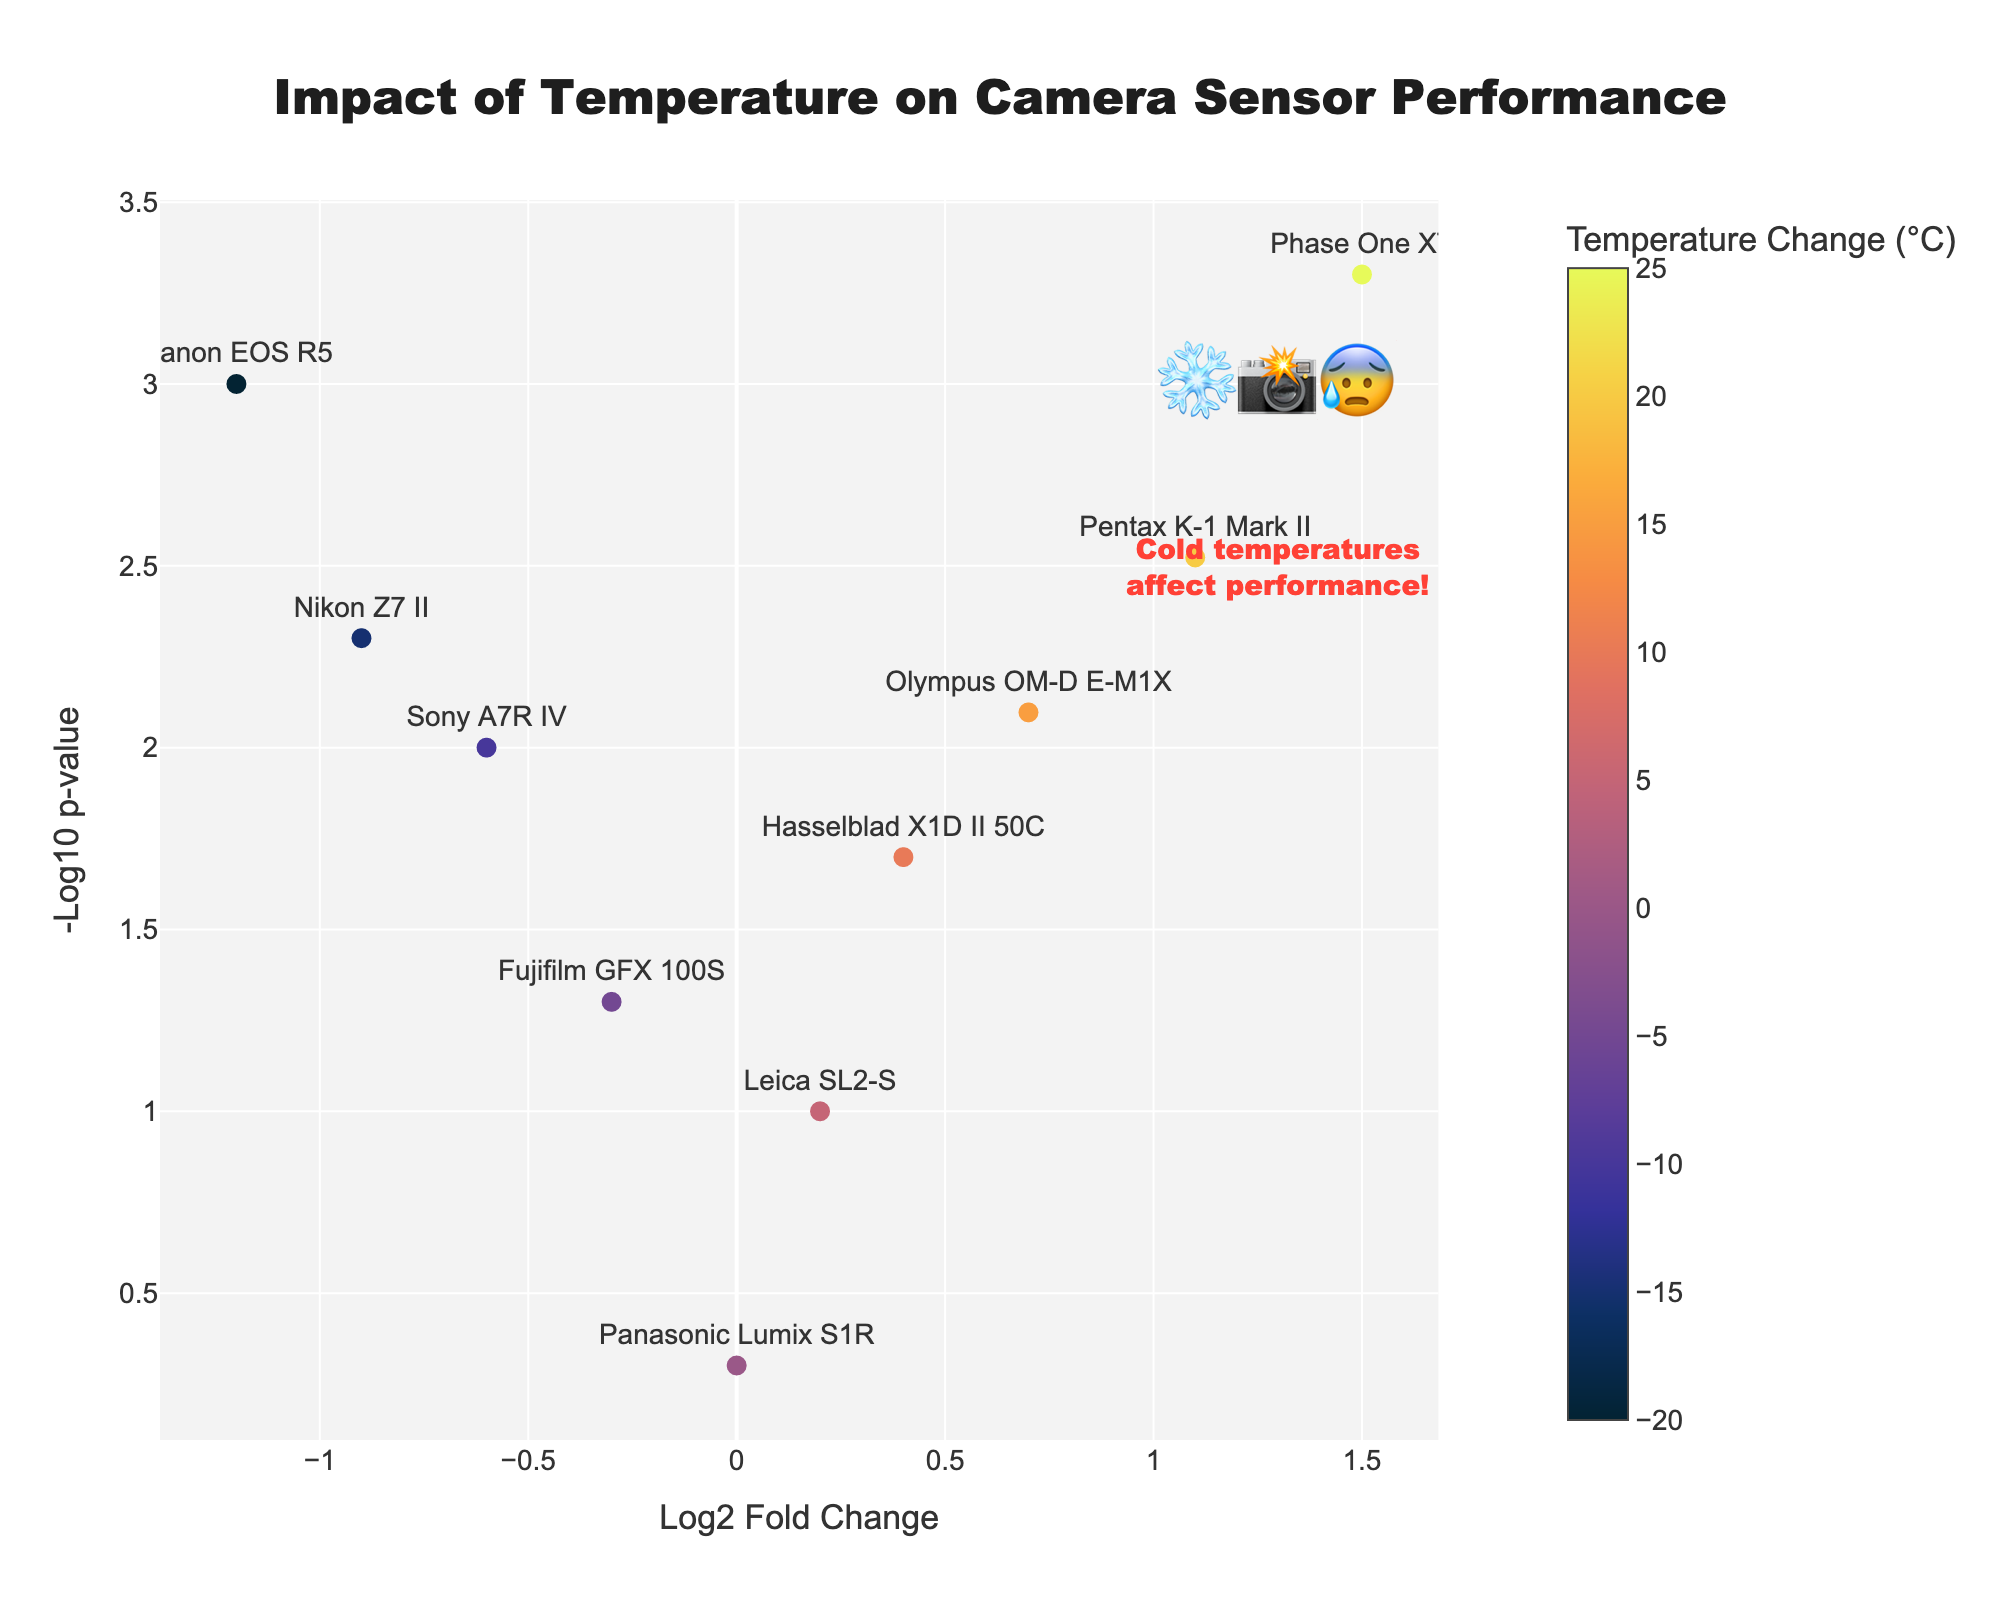what is the title of the figure? The title is typically displayed at the top of the figure. In this plot, it's centered at the top and prominently sized. It reads, "Impact of Temperature on Camera Sensor Performance".
Answer: Impact of Temperature on Camera Sensor Performance How many camera models are included in the figure? Count the number of different text labels representing camera models in the scatter plot. There are 10 different camera models.
Answer: 10 Which camera shows the largest impact due to cold temperatures? Look for the most negative log2 fold change value and identify the corresponding camera model. Canon EOS R5 shows the largest negative impact with a log2 fold change of -1.2.
Answer: Canon EOS R5 Which camera shows the least impact (close to no change) due to temperature? Look for the log2 fold change value closest to 0. Panasonic Lumix S1R has a log2 fold change of 0, indicating the least impact.
Answer: Panasonic Lumix S1R Are there more cameras positively or negatively affected by temperature changes? Compare the number of data points on the right side (positive log2 fold change) to those on the left side (negative log2 fold change). There are 6 cameras positively affected and 4 cameras negatively affected.
Answer: More positively affected What is the camera with the highest positive log2 fold change value? Identify the camera model with the highest log2 fold change value. The Phase One XT has the highest positive log2 fold change at 1.5.
Answer: Phase One XT Which camera model has the most statistically significant impact according to the p-values? Check for the camera model with the highest value on the y-axis (-log10(p-value)). Phase One XT has the highest -log10(p-value) of 3.3, indicating the most statistically significant impact.
Answer: Phase One XT What is the temperature change difference between the cameras with the highest and lowest log2 fold changes? Find the difference in temperature change values between Phase One XT (highest log2 fold change of 1.5) and Canon EOS R5 (lowest log2 fold change of -1.2). The difference is 45°C.
Answer: 45°C What kind of trend is observed for cameras when temperature increases? Assess the log2 fold change values as the temperature change increases. Generally, cameras show a trend of positive log2 fold changes with increasing temperatures, indicating performance improvement.
Answer: Positive trend How does the Nikon Z7 II compare to the Olympus OM-D E-M1X in terms of temperature impact and statistical significance? Nikon Z7 II has a negative log2 fold change and a less statistically significant impact compared to Olympus OM-D E-M1X which has a positive log2 fold change and higher -log10(p-value).
Answer: Olympus OM-D E-M1X shows a better performance and higher significance 